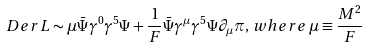<formula> <loc_0><loc_0><loc_500><loc_500>\ D e r { L } \sim \mu \bar { \Psi } \gamma ^ { 0 } \gamma ^ { 5 } \Psi + \frac { 1 } { F } \bar { \Psi } \gamma ^ { \mu } \gamma ^ { 5 } \Psi \partial _ { \mu } \pi , \, w h e r e \, \mu \equiv \frac { M ^ { 2 } } { F }</formula> 